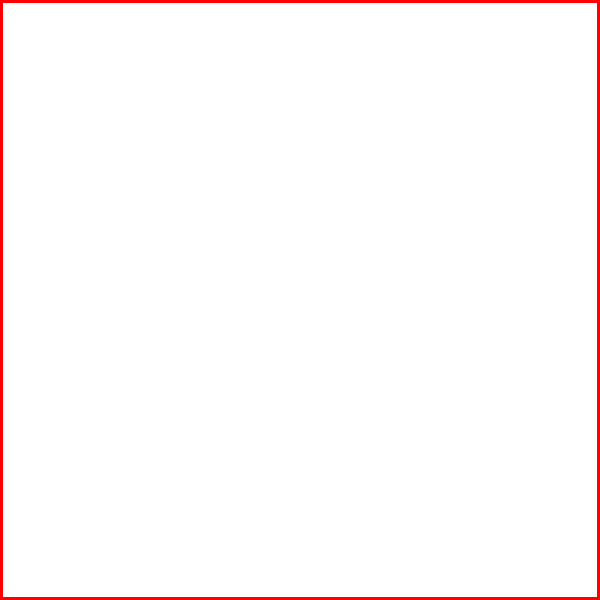In the image above, the England national team logo (simplified as a square) is reflected across a vertical axis of symmetry. Which geometric transformation would make the reflected logo congruent to the original? To determine the geometric transformation that would make the reflected logo congruent to the original, let's follow these steps:

1. Observe the original logo (red) and its reflection (blue).
2. Note that the reflection is across a vertical axis of symmetry.
3. The reflected logo is congruent in shape and size to the original, but its orientation is different.
4. To make the reflected logo identical to the original, we need to "undo" the reflection.
5. The transformation that undoes a reflection is another reflection across the same axis.
6. Alternatively, we can rotate the reflected logo 180° around the point where it intersects the axis of symmetry.

Therefore, either a second reflection across the same vertical axis or a 180° rotation around the point of intersection with the axis of symmetry would make the reflected logo congruent to the original.
Answer: Reflection across the same axis or 180° rotation 